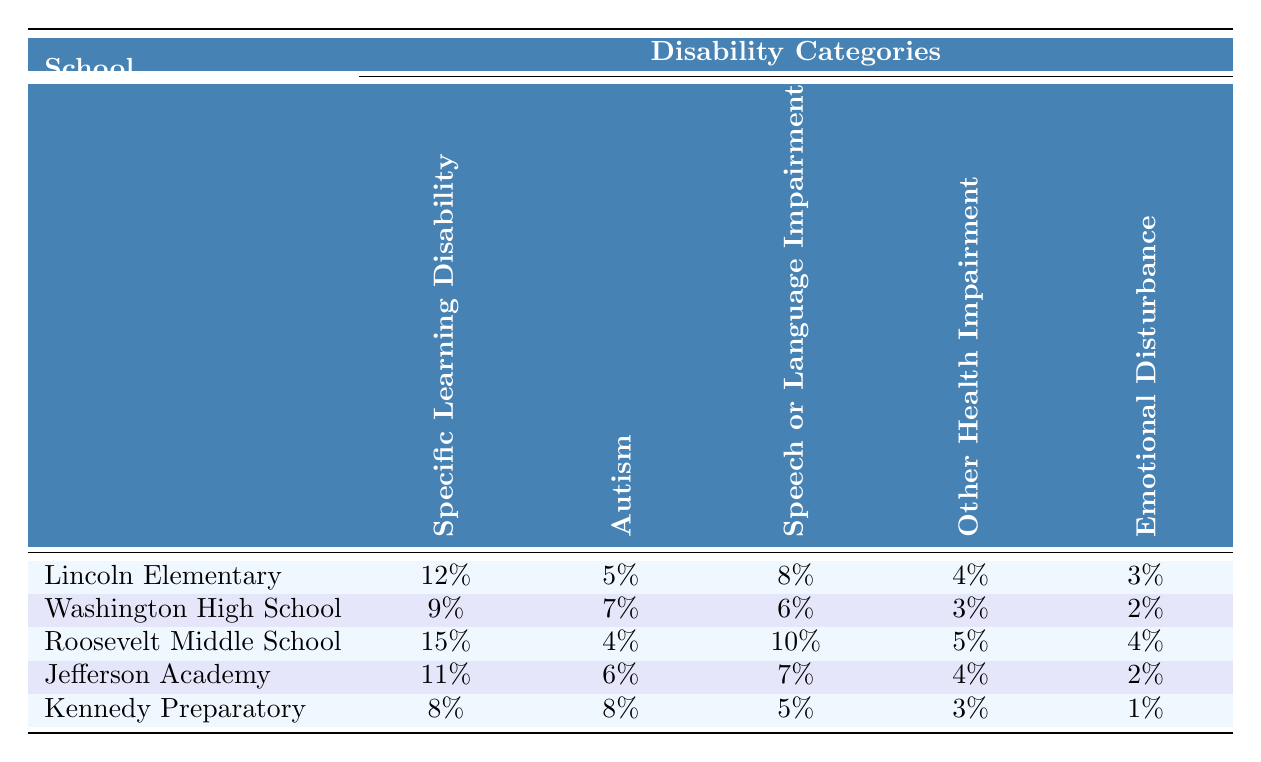What is the enrollment rate for Autism at Lincoln Elementary? The table shows that the enrollment rate for Autism at Lincoln Elementary is listed under the corresponding row and column, which is 5%.
Answer: 5% Which school has the highest enrollment rate for Specific Learning Disability? By looking at the first column, Lincoln Elementary has the highest enrollment rate for Specific Learning Disability at 12%.
Answer: Lincoln Elementary What is the combined enrollment rate for Emotional Disturbance and Speech or Language Impairment at Jefferson Academy? The enrollment rate for Emotional Disturbance at Jefferson Academy is 2%, and for Speech or Language Impairment, it is 7%. Combining these gives 2% + 7% = 9%.
Answer: 9% Is the enrollment rate for Other Health Impairment at Kennedy Preparatory less than that at Washington High School? The enrollment rate for Other Health Impairment at Kennedy Preparatory is 3%, while at Washington High School it is 3% as well. Since they are equal, the statement is false.
Answer: No What is the average enrollment rate for Autism across all schools? To find the average enrollment rate for Autism, sum the values across all the schools: 5% + 7% + 4% + 6% + 8% = 30%. Then divide by the number of schools (5): 30% / 5 = 6%.
Answer: 6% Which school has the lowest overall enrollment rate for Special Education programs? By checking all the enrollment rates, Kennedy Preparatory has the lowest values, especially with the lowest in Emotional Disturbance at 1%, giving it a lower overall average.
Answer: Kennedy Preparatory What is the difference in enrollment rates for Autism between Roosevelt Middle School and Kennedy Preparatory? The enrollment rate for Autism at Roosevelt Middle School is 4%, while at Kennedy Preparatory it is 8%. The difference is 8% - 4% = 4%.
Answer: 4% Are there any schools with no enrollment for Emotional Disturbance? Looking at the enrollment rates, all schools have some enrollment in Emotional Disturbance, as each has a value greater than 0%. So, there are no schools with 0% enrollment in this category.
Answer: No 